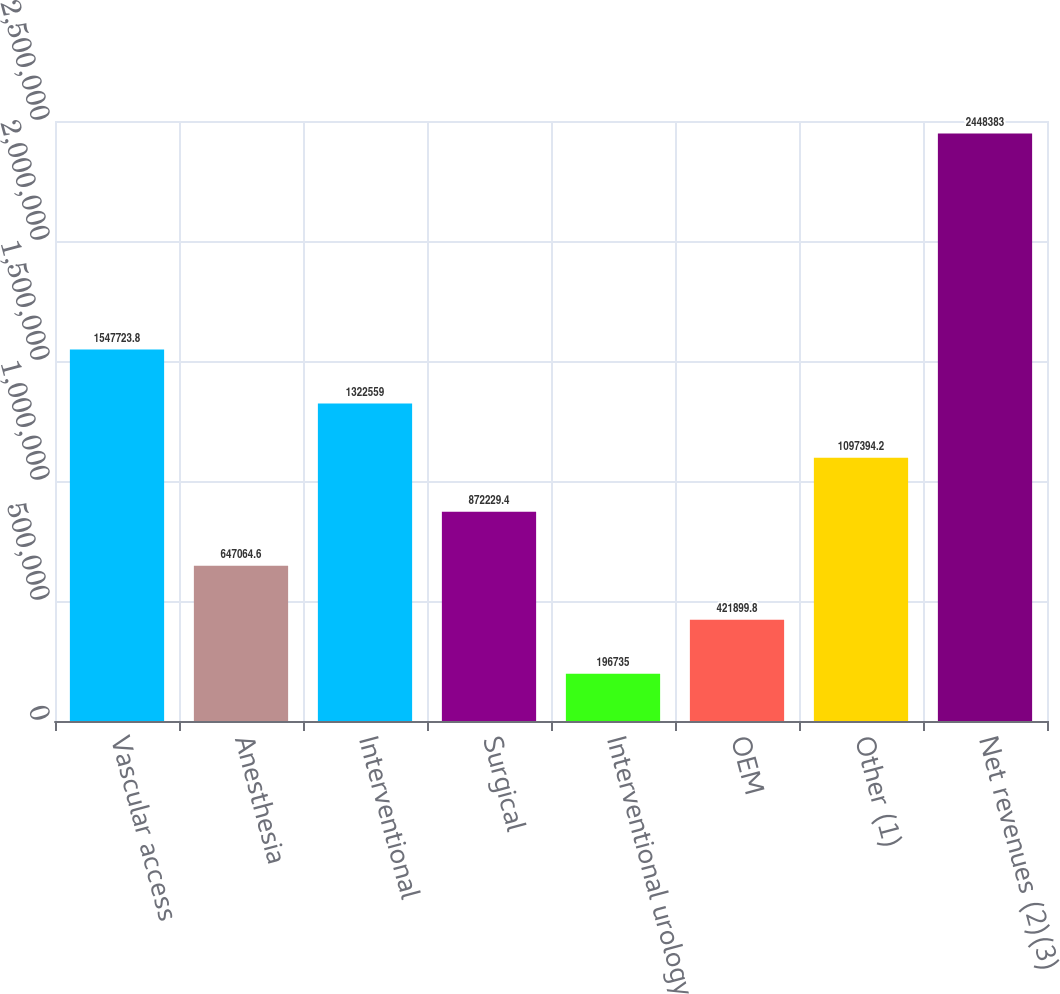<chart> <loc_0><loc_0><loc_500><loc_500><bar_chart><fcel>Vascular access<fcel>Anesthesia<fcel>Interventional<fcel>Surgical<fcel>Interventional urology<fcel>OEM<fcel>Other (1)<fcel>Net revenues (2)(3)<nl><fcel>1.54772e+06<fcel>647065<fcel>1.32256e+06<fcel>872229<fcel>196735<fcel>421900<fcel>1.09739e+06<fcel>2.44838e+06<nl></chart> 